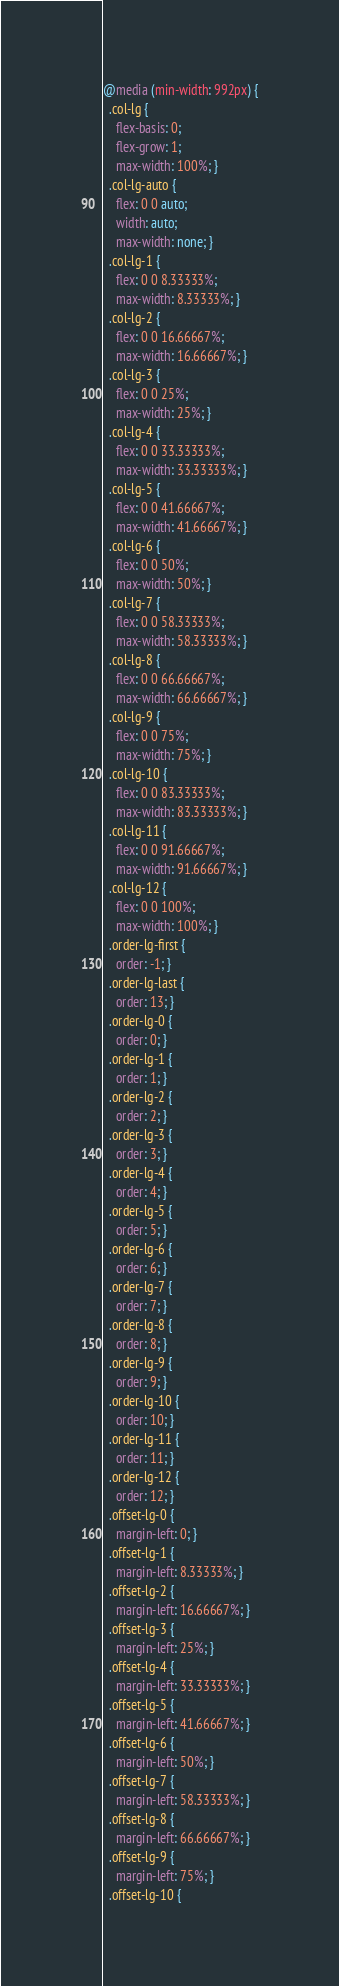Convert code to text. <code><loc_0><loc_0><loc_500><loc_500><_CSS_>@media (min-width: 992px) {
  .col-lg {
    flex-basis: 0;
    flex-grow: 1;
    max-width: 100%; }
  .col-lg-auto {
    flex: 0 0 auto;
    width: auto;
    max-width: none; }
  .col-lg-1 {
    flex: 0 0 8.33333%;
    max-width: 8.33333%; }
  .col-lg-2 {
    flex: 0 0 16.66667%;
    max-width: 16.66667%; }
  .col-lg-3 {
    flex: 0 0 25%;
    max-width: 25%; }
  .col-lg-4 {
    flex: 0 0 33.33333%;
    max-width: 33.33333%; }
  .col-lg-5 {
    flex: 0 0 41.66667%;
    max-width: 41.66667%; }
  .col-lg-6 {
    flex: 0 0 50%;
    max-width: 50%; }
  .col-lg-7 {
    flex: 0 0 58.33333%;
    max-width: 58.33333%; }
  .col-lg-8 {
    flex: 0 0 66.66667%;
    max-width: 66.66667%; }
  .col-lg-9 {
    flex: 0 0 75%;
    max-width: 75%; }
  .col-lg-10 {
    flex: 0 0 83.33333%;
    max-width: 83.33333%; }
  .col-lg-11 {
    flex: 0 0 91.66667%;
    max-width: 91.66667%; }
  .col-lg-12 {
    flex: 0 0 100%;
    max-width: 100%; }
  .order-lg-first {
    order: -1; }
  .order-lg-last {
    order: 13; }
  .order-lg-0 {
    order: 0; }
  .order-lg-1 {
    order: 1; }
  .order-lg-2 {
    order: 2; }
  .order-lg-3 {
    order: 3; }
  .order-lg-4 {
    order: 4; }
  .order-lg-5 {
    order: 5; }
  .order-lg-6 {
    order: 6; }
  .order-lg-7 {
    order: 7; }
  .order-lg-8 {
    order: 8; }
  .order-lg-9 {
    order: 9; }
  .order-lg-10 {
    order: 10; }
  .order-lg-11 {
    order: 11; }
  .order-lg-12 {
    order: 12; }
  .offset-lg-0 {
    margin-left: 0; }
  .offset-lg-1 {
    margin-left: 8.33333%; }
  .offset-lg-2 {
    margin-left: 16.66667%; }
  .offset-lg-3 {
    margin-left: 25%; }
  .offset-lg-4 {
    margin-left: 33.33333%; }
  .offset-lg-5 {
    margin-left: 41.66667%; }
  .offset-lg-6 {
    margin-left: 50%; }
  .offset-lg-7 {
    margin-left: 58.33333%; }
  .offset-lg-8 {
    margin-left: 66.66667%; }
  .offset-lg-9 {
    margin-left: 75%; }
  .offset-lg-10 {</code> 